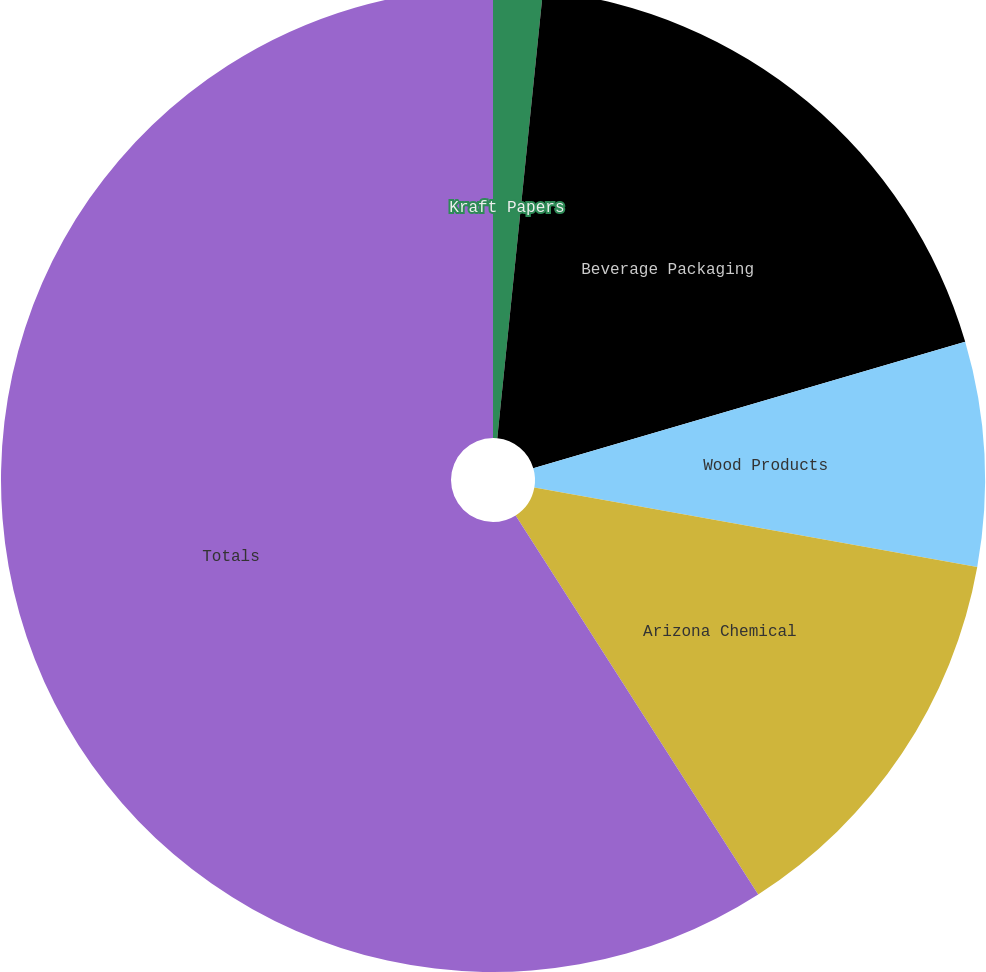Convert chart. <chart><loc_0><loc_0><loc_500><loc_500><pie_chart><fcel>Kraft Papers<fcel>Beverage Packaging<fcel>Wood Products<fcel>Arizona Chemical<fcel>Totals<nl><fcel>1.62%<fcel>18.85%<fcel>7.36%<fcel>13.11%<fcel>59.06%<nl></chart> 